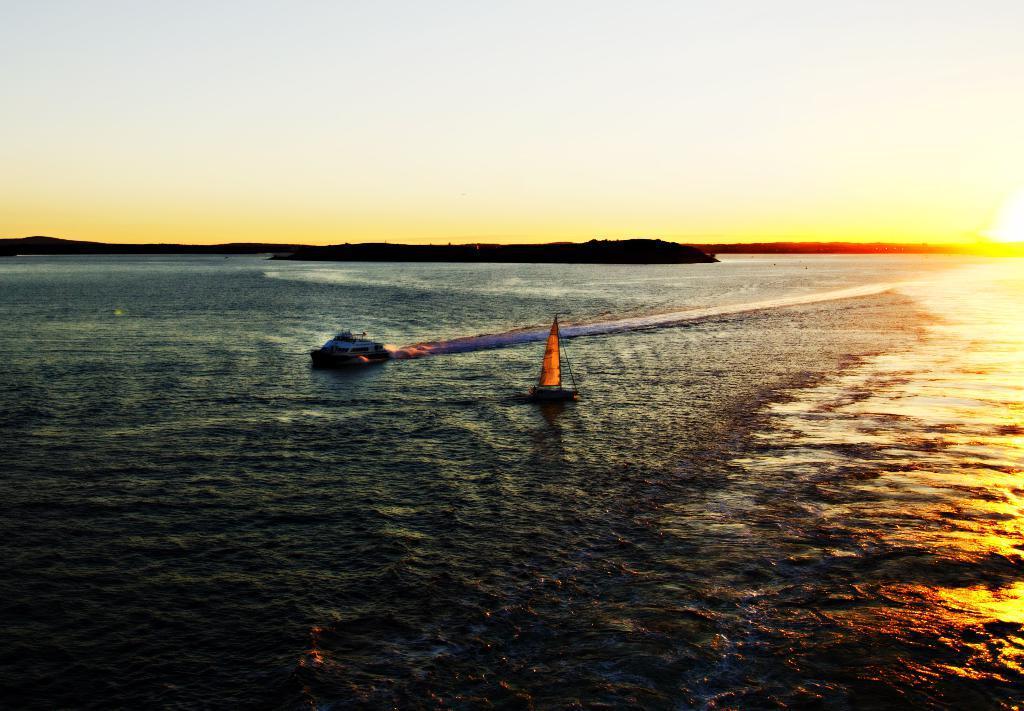Please provide a concise description of this image. In this image, there is an outside view. In the foreground, there are boats floating on the sea. In the background, there is a sky. 